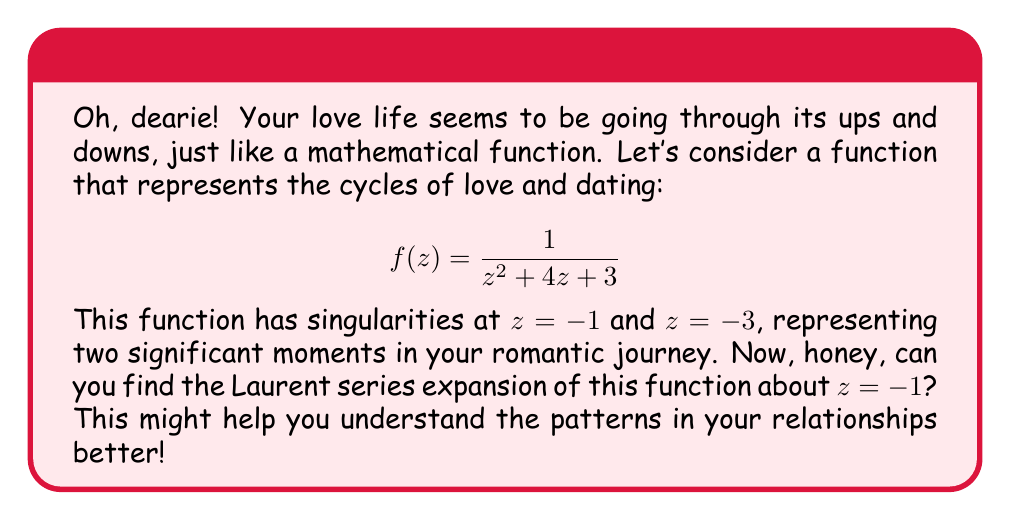Give your solution to this math problem. Alright, sweetheart, let's break this down step-by-step:

1) First, we need to rewrite our function in terms of $(z+1)$:
   $$f(z) = \frac{1}{z^2 + 4z + 3} = \frac{1}{(z+1)(z+3)}$$

2) Now, we can express this as a partial fraction:
   $$f(z) = \frac{1/2}{z+1} - \frac{1/2}{z+3}$$

3) Let's focus on the term $\frac{1/2}{z+1}$. This is already in the form of a Laurent series about $z = -1$.

4) For the term $\frac{1/2}{z+3}$, we need to expand it as a geometric series:
   $$\frac{1/2}{z+3} = \frac{1/2}{(z+1)+2} = \frac{1/4}{1+\frac{z+1}{2}}$$
   $$= \frac{1}{4}\left(1 - \frac{z+1}{2} + \frac{(z+1)^2}{4} - \frac{(z+1)^3}{8} + ...\right)$$

5) Combining the results from steps 3 and 4:
   $$f(z) = \frac{1/2}{z+1} - \frac{1}{4} + \frac{z+1}{8} - \frac{(z+1)^2}{16} + \frac{(z+1)^3}{32} - ...$$

This, my dear, is the Laurent series expansion of $f(z)$ about $z = -1$. It shows how your love life might have its intense moments (represented by the term $\frac{1/2}{z+1}$) and then settle into a pattern of smaller ups and downs.
Answer: $$f(z) = \frac{1/2}{z+1} - \frac{1}{4} + \frac{z+1}{8} - \frac{(z+1)^2}{16} + \frac{(z+1)^3}{32} - ...$$ 